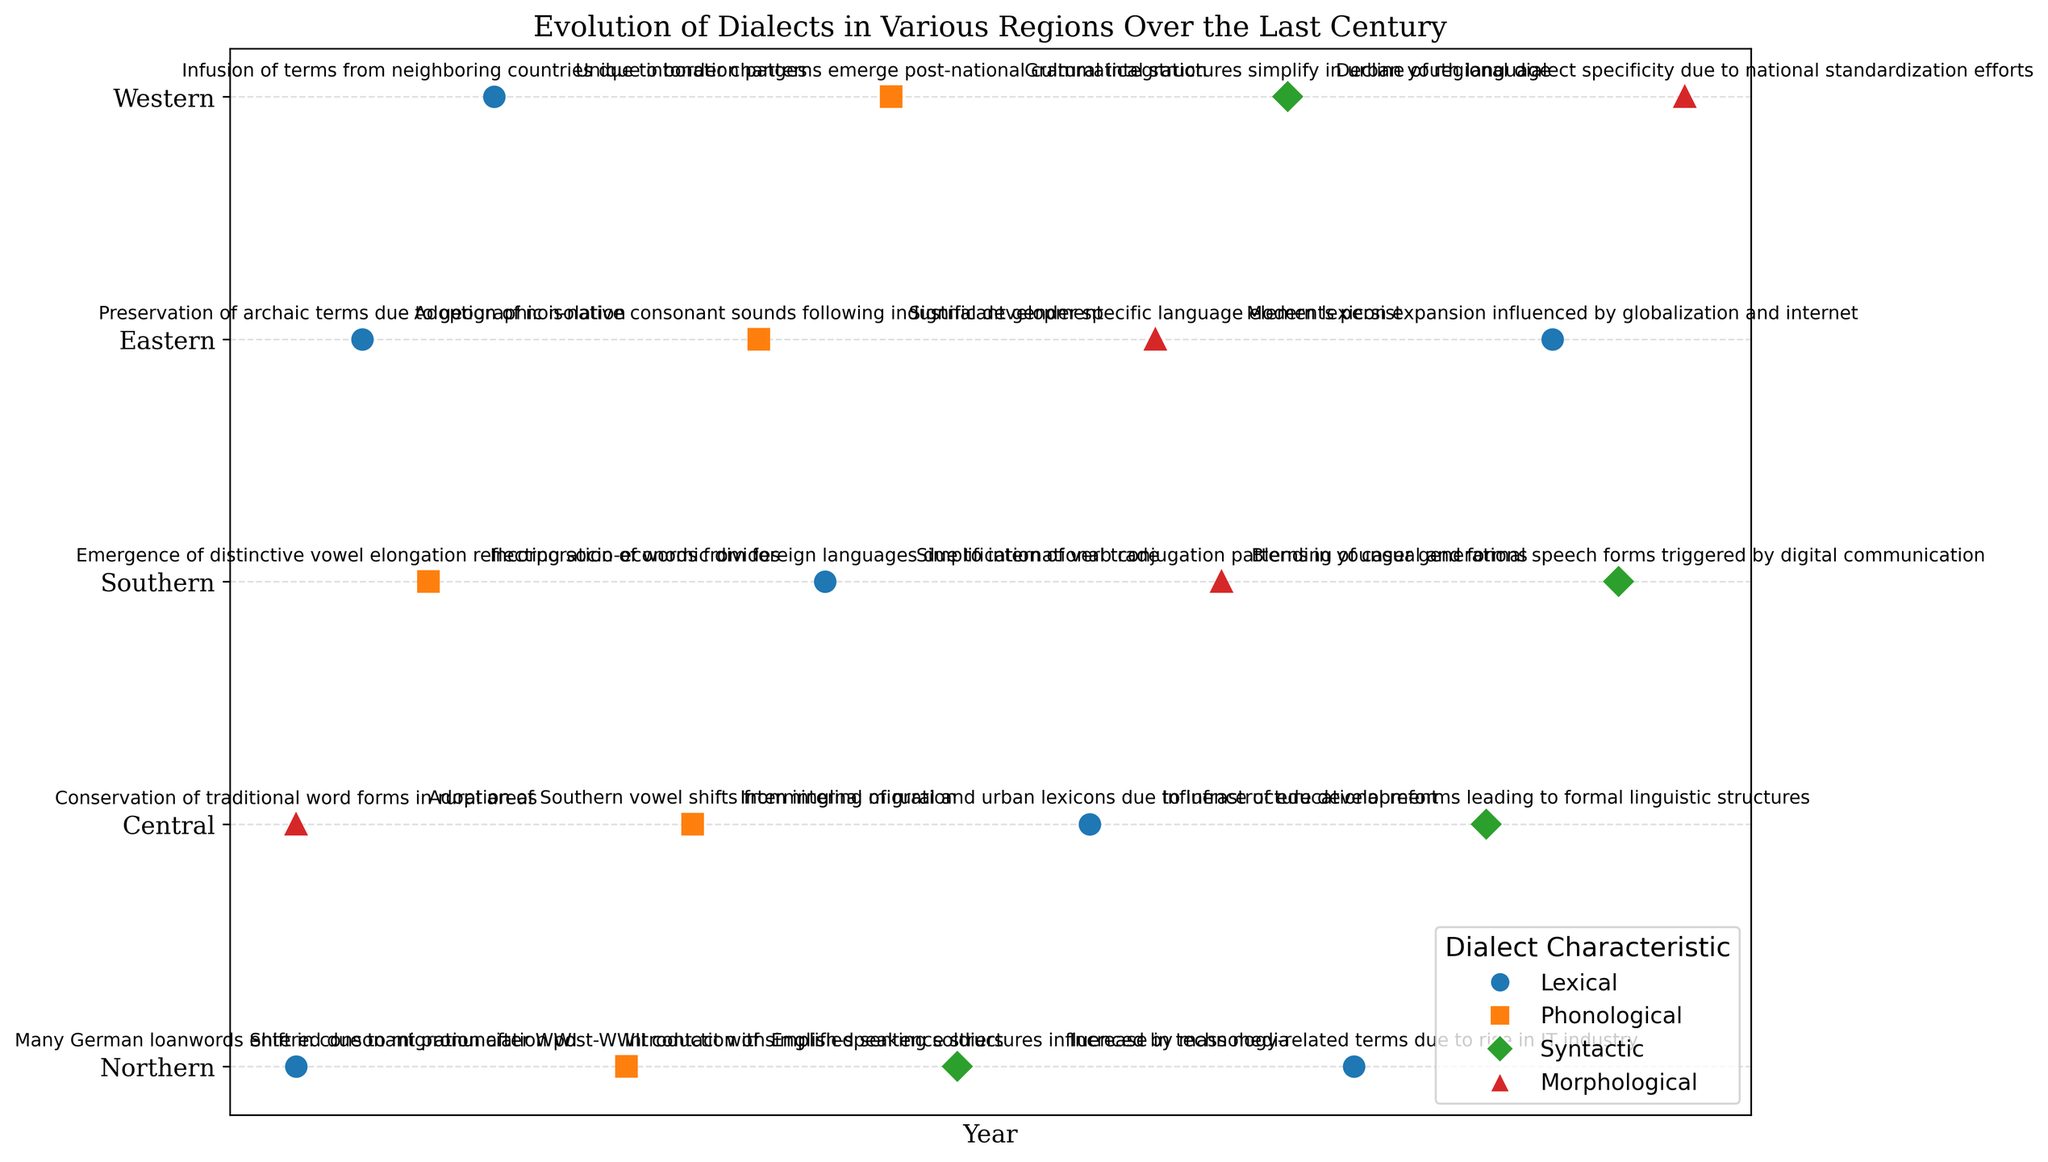Which region shows a lexical evolution due to the rise in the IT industry? By looking at the color associated with 'Lexical' (blue) and the text annotations, one can identify which region has a note mentioning the rise in the IT industry related to lexical changes. The Northern region in 2000 has the specific annotation mentioning the rise of the IT industry.
Answer: Northern Which type of dialect characteristic is most frequently associated with the Southern region? We look at the markers corresponding to different dialect characteristics for the Southern region (rows on the y-axis labeled "Southern"). By counting the markers, we see that the Southern region has lexical (blue o), phonological (orange s), morphological (red ^), and syntactic (green D) represented. 'Lexical' and 'Phonological' both appear twice across the timeline.
Answer: Lexical and Phonological What is the earliest morphological change and in which region did it occur? Morphological changes are indicated by the red triangles (^). By finding the earliest (leftmost on the x-axis) red triangle, we see it occurs in the Central region in 1920.
Answer: Central, 1920 Compare the extent of syntactic changes between Central and Western regions. Which one has more instances? Syntactic changes are represented by green diamonds (D). By checking the Central and Western regions' rows, Central has one syntactic change in 2010, and Western also has one in 1995. Both have one syntactic change each.
Answer: Equal Identify the region with a phonological evolution due to international influences in the 20th century. Phonological changes are indicated by orange squares (s). Reading the annotations, 'international influences' is specifically mentioned in the Southern region in 1960.
Answer: Southern How many regions show lexical changes as a result of globalization or technological advancements? Lexical changes are shown by blue circles (o). By reading annotations, Northern in 2000 mentions 'technology-related terms due to IT industry,' and Eastern in 2015 mentions 'globalization and the internet.'
Answer: 2 regions Which region has a dialect evolution described as the blending of casual and formal speech forms, and in what year? Reviewing the annotations, 'blending of casual and formal speech forms' is noted in the Southern region in 2020.
Answer: Southern, 2020 Compare the appearance of phonological changes in the Northern and Eastern regions. Which has more occurrences, and by how many? Phonological changes are shown by orange squares (s). The Northern region has marks in 1945, and the Eastern region in 1955. Both regions show one occurrence each.
Answer: Equal 